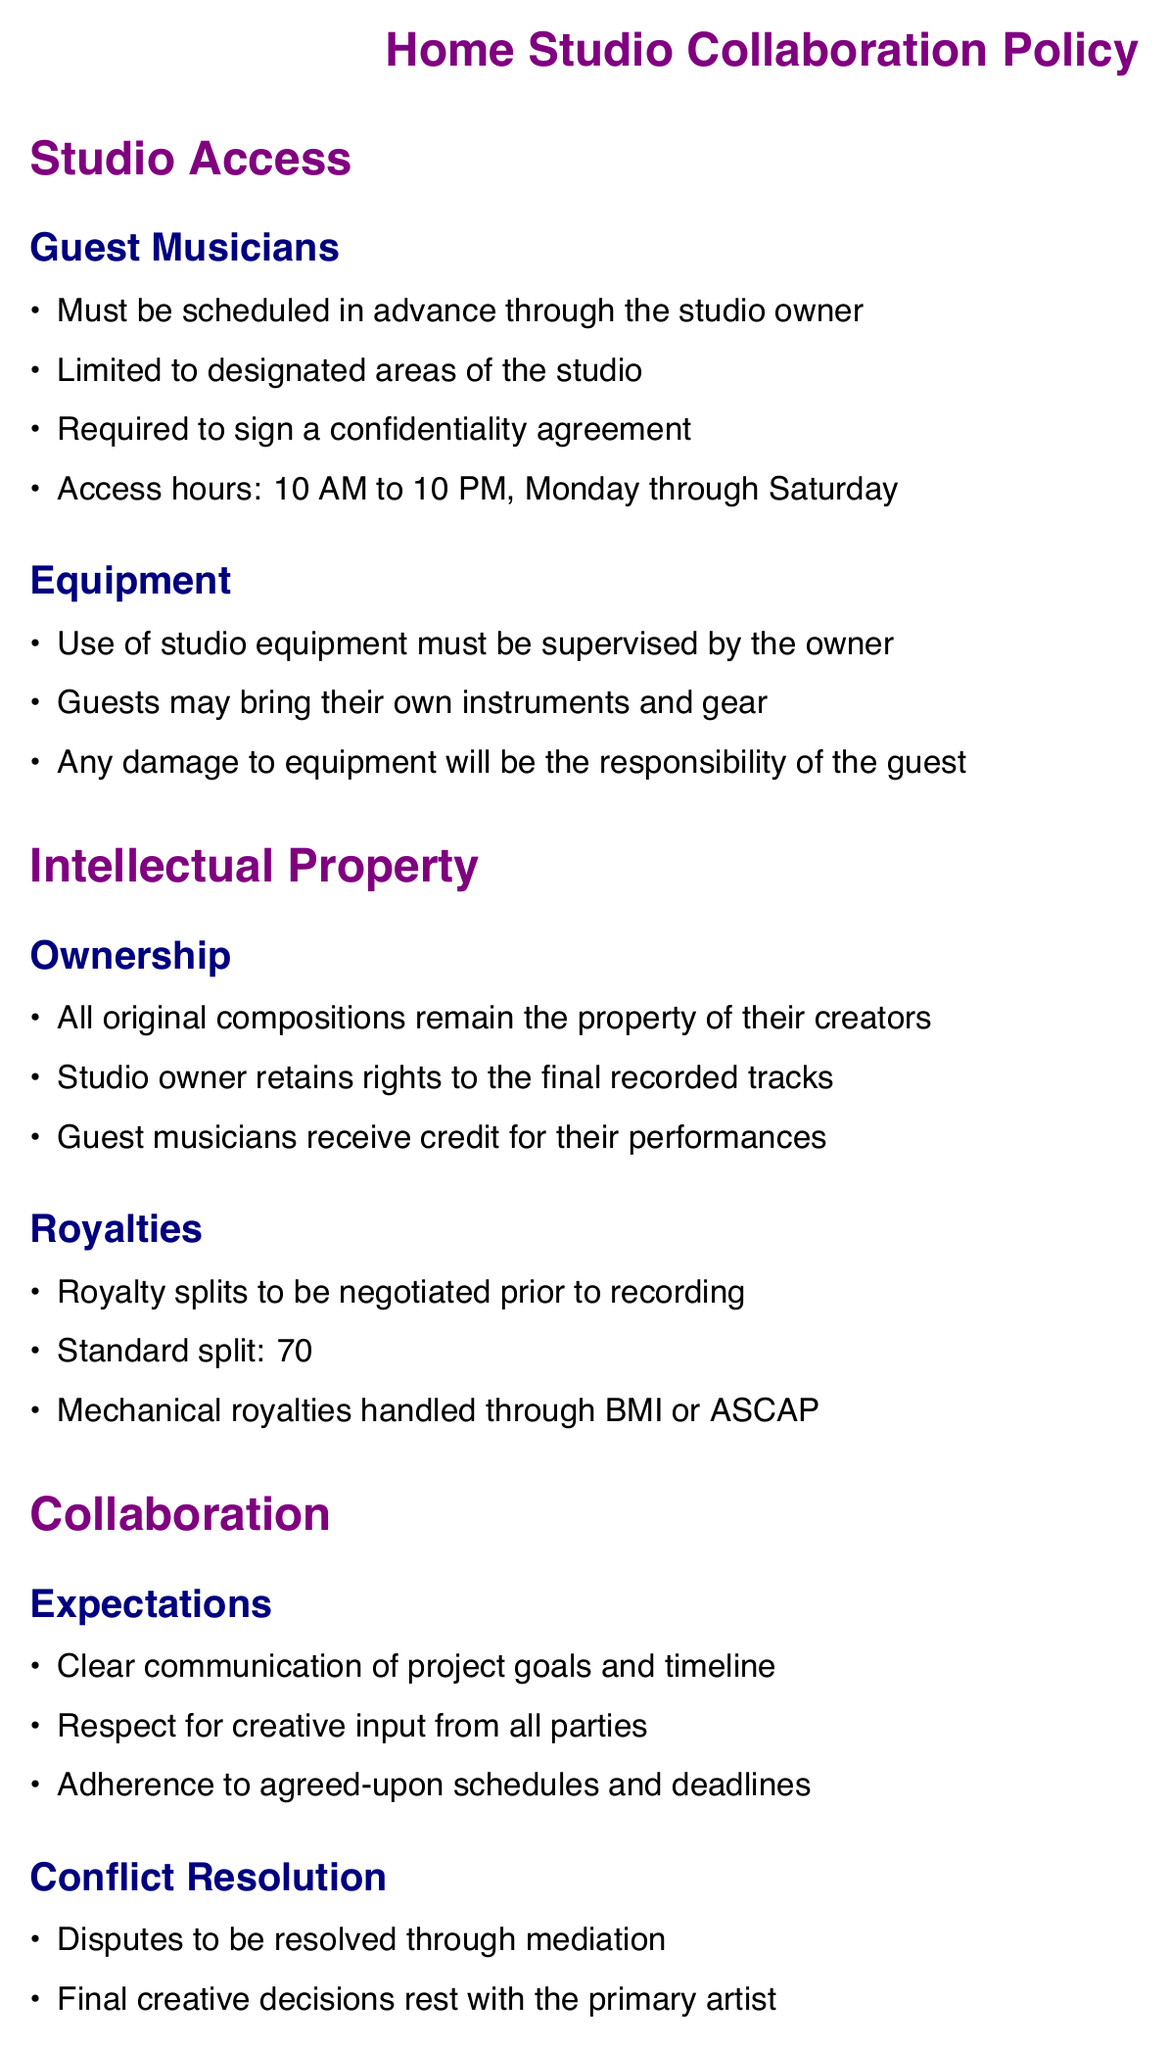What are the access hours for guest musicians? The document specifies the access hours for guest musicians, which are from 10 AM to 10 PM, Monday through Saturday.
Answer: 10 AM to 10 PM, Monday through Saturday What is the standard royalty split for guest musicians? The document outlines the standard royalty split, which is divided between the primary artist and the guest musician.
Answer: 70% primary artist, 30% guest musician Who retains the rights to the final recorded tracks? The ownership section specifies that the studio owner retains rights to the final recorded tracks.
Answer: Studio owner What must guest musicians sign before accessing the studio? The document states that guest musicians are required to sign a confidentiality agreement before studio access.
Answer: Confidentiality agreement What is the maximum duration for recording sessions? The sessions section of the document specifies the maximum length allowed for recording sessions.
Answer: 8 hours What must be provided by the studio owner during sessions? The document mentions that food and beverages are to be provided by the studio owner during recording sessions.
Answer: Food and beverages How are disputes resolved according to the policy? The policy specifies that disputes are to be resolved through a specific process outlined in the conflict resolution section.
Answer: Mediation What kind of files will be provided as deliverables? The deliverables section notes the format of the files that will be provided to collaborators after the recording sessions.
Answer: High-quality WAV files What is needed for the use of studio equipment? The equipment section states that the use of studio equipment must be supervised by a designated individual.
Answer: Supervised by the owner 